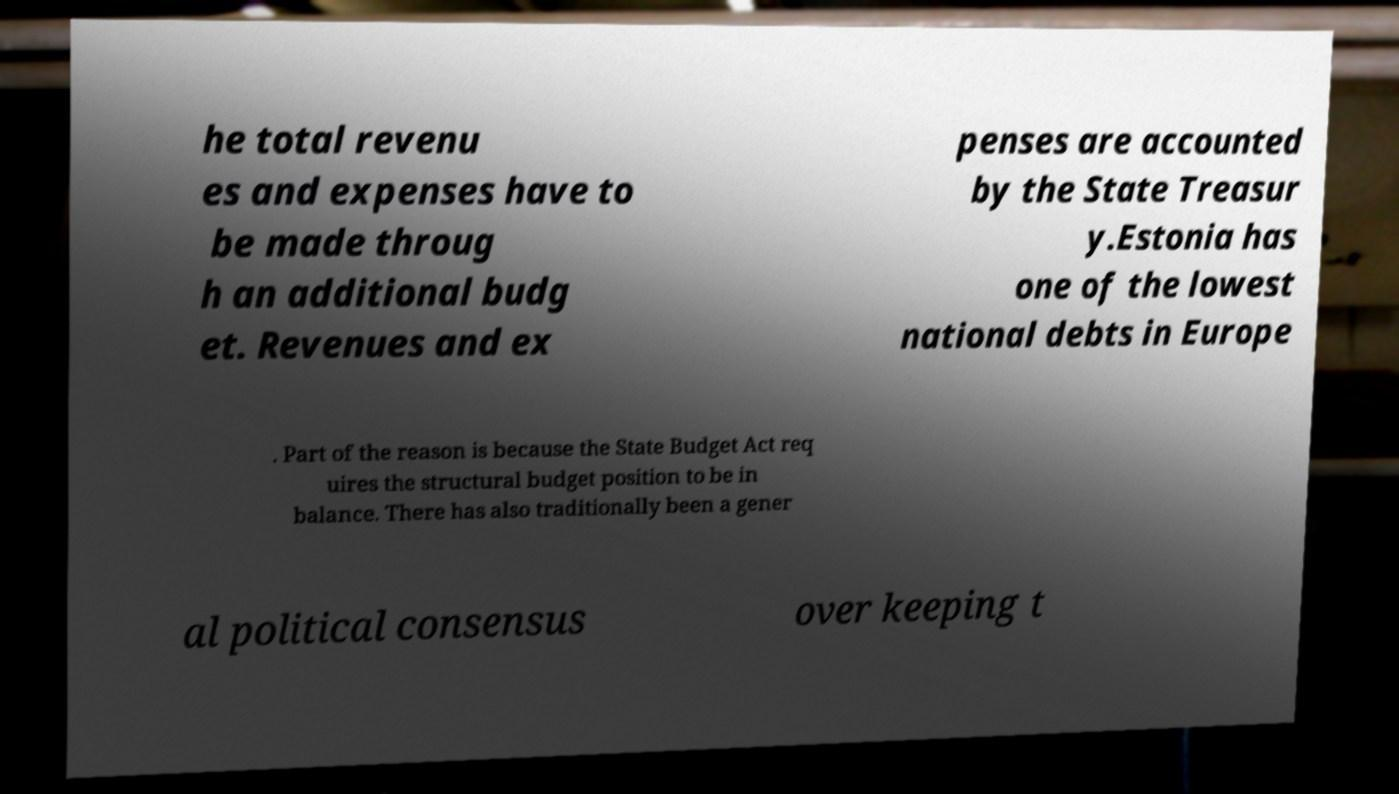Please read and relay the text visible in this image. What does it say? he total revenu es and expenses have to be made throug h an additional budg et. Revenues and ex penses are accounted by the State Treasur y.Estonia has one of the lowest national debts in Europe . Part of the reason is because the State Budget Act req uires the structural budget position to be in balance. There has also traditionally been a gener al political consensus over keeping t 